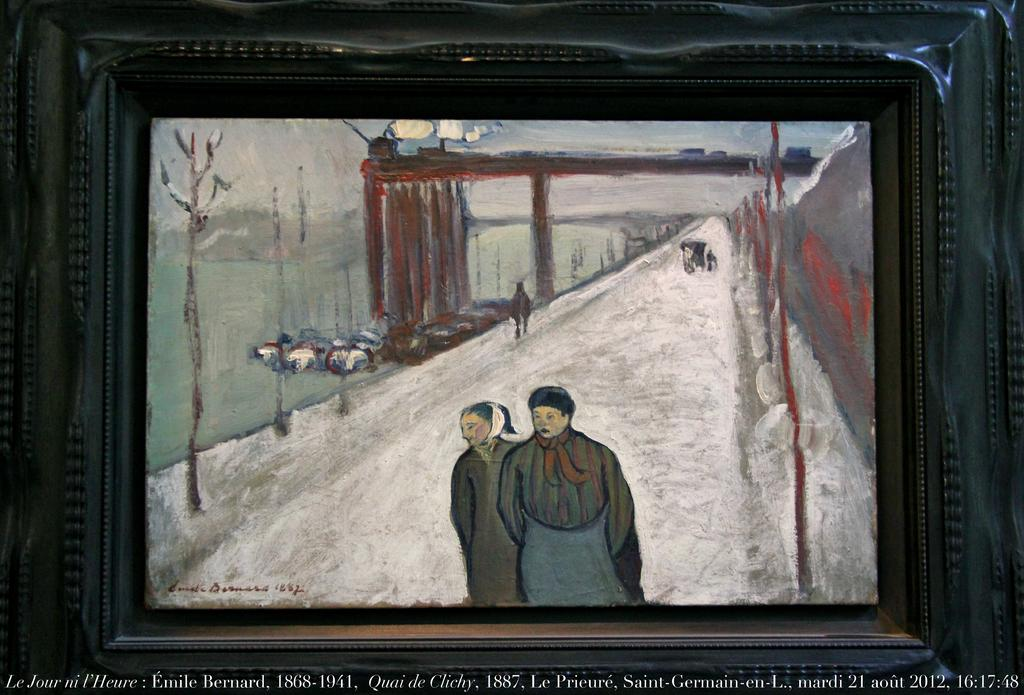Provide a one-sentence caption for the provided image. A painting sits above some information stating that Emile Bernard lived from 1868 to 1941. 